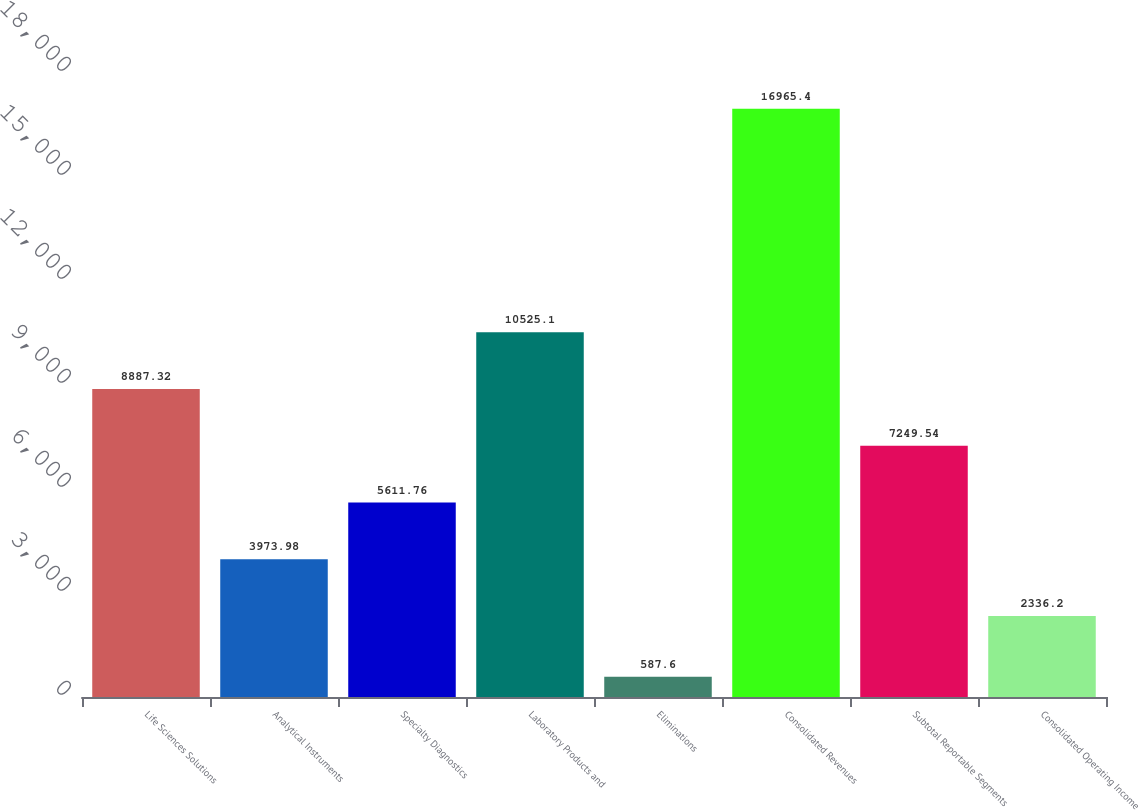<chart> <loc_0><loc_0><loc_500><loc_500><bar_chart><fcel>Life Sciences Solutions<fcel>Analytical Instruments<fcel>Specialty Diagnostics<fcel>Laboratory Products and<fcel>Eliminations<fcel>Consolidated Revenues<fcel>Subtotal Reportable Segments<fcel>Consolidated Operating Income<nl><fcel>8887.32<fcel>3973.98<fcel>5611.76<fcel>10525.1<fcel>587.6<fcel>16965.4<fcel>7249.54<fcel>2336.2<nl></chart> 